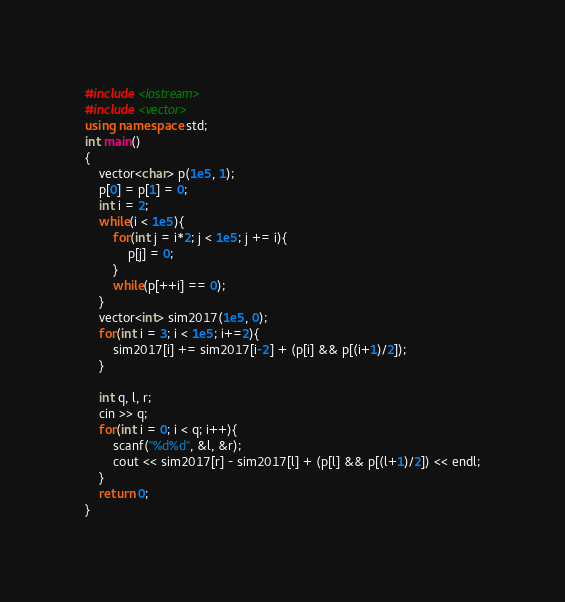<code> <loc_0><loc_0><loc_500><loc_500><_C++_>#include <iostream>
#include <vector>
using namespace std;
int main()
{
    vector<char> p(1e5, 1);
    p[0] = p[1] = 0;
    int i = 2;
    while(i < 1e5){
        for(int j = i*2; j < 1e5; j += i){
            p[j] = 0;
        }
        while(p[++i] == 0);
    }
    vector<int> sim2017(1e5, 0);
    for(int i = 3; i < 1e5; i+=2){
        sim2017[i] += sim2017[i-2] + (p[i] && p[(i+1)/2]);
    }

    int q, l, r;
    cin >> q;
    for(int i = 0; i < q; i++){
        scanf("%d%d", &l, &r);
        cout << sim2017[r] - sim2017[l] + (p[l] && p[(l+1)/2]) << endl;
    }
    return 0;
}</code> 